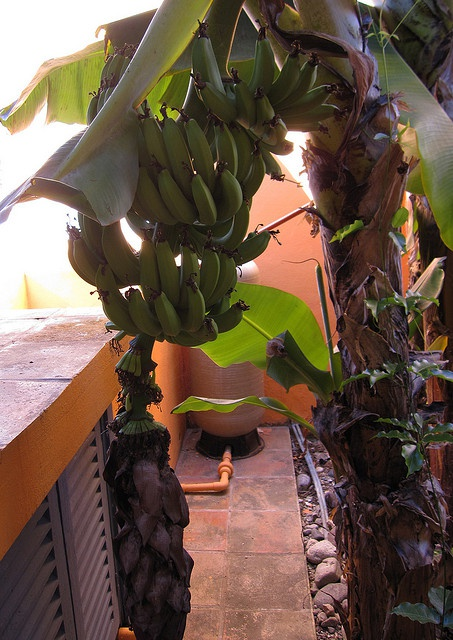Describe the objects in this image and their specific colors. I can see banana in white, black, darkgreen, and gray tones, banana in white, black, darkgreen, and gray tones, banana in white, black, maroon, and gray tones, banana in white, black, darkgreen, and olive tones, and banana in white, black, darkgreen, and gray tones in this image. 